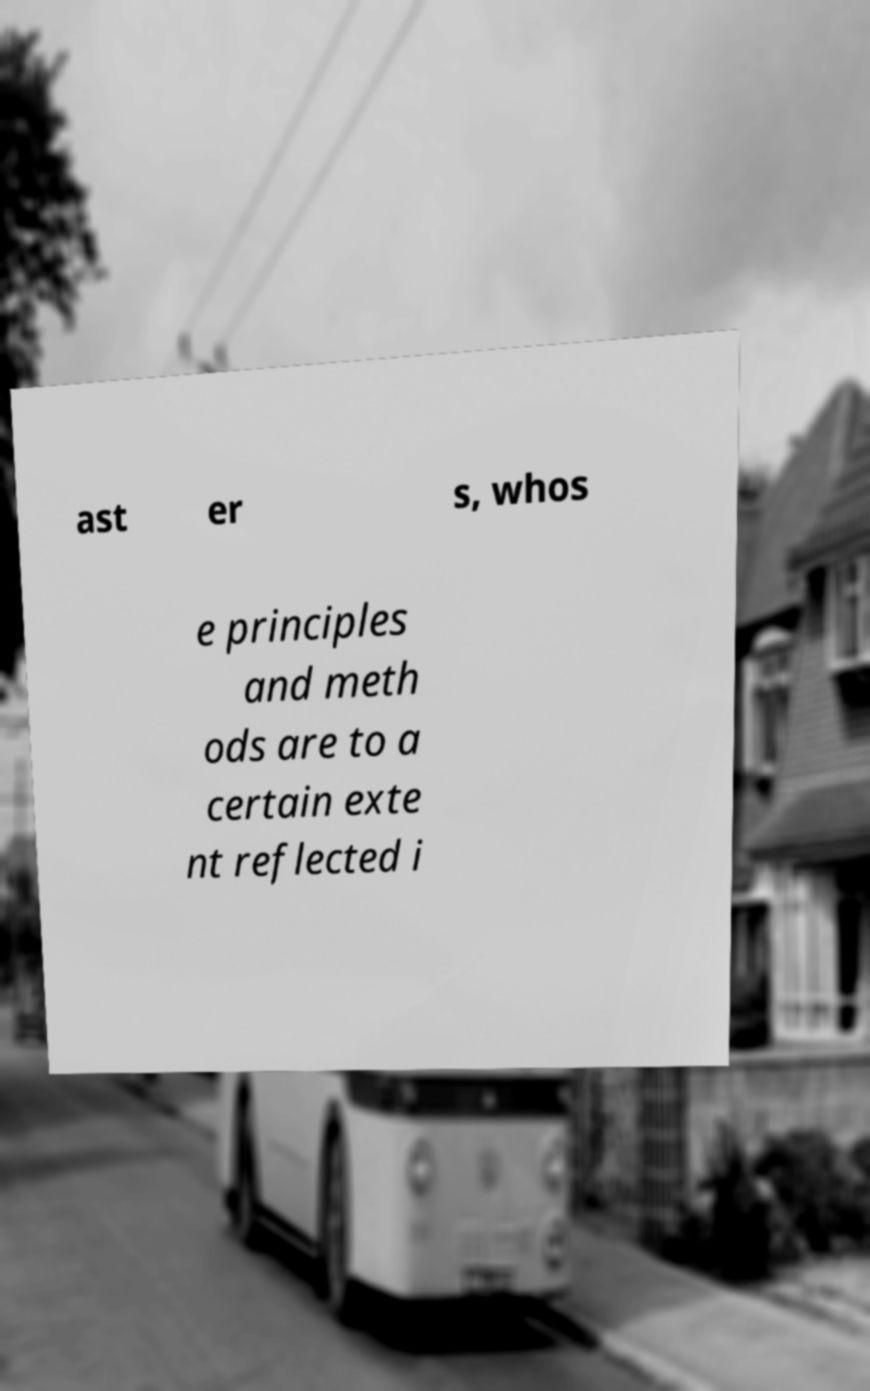Can you read and provide the text displayed in the image?This photo seems to have some interesting text. Can you extract and type it out for me? ast er s, whos e principles and meth ods are to a certain exte nt reflected i 